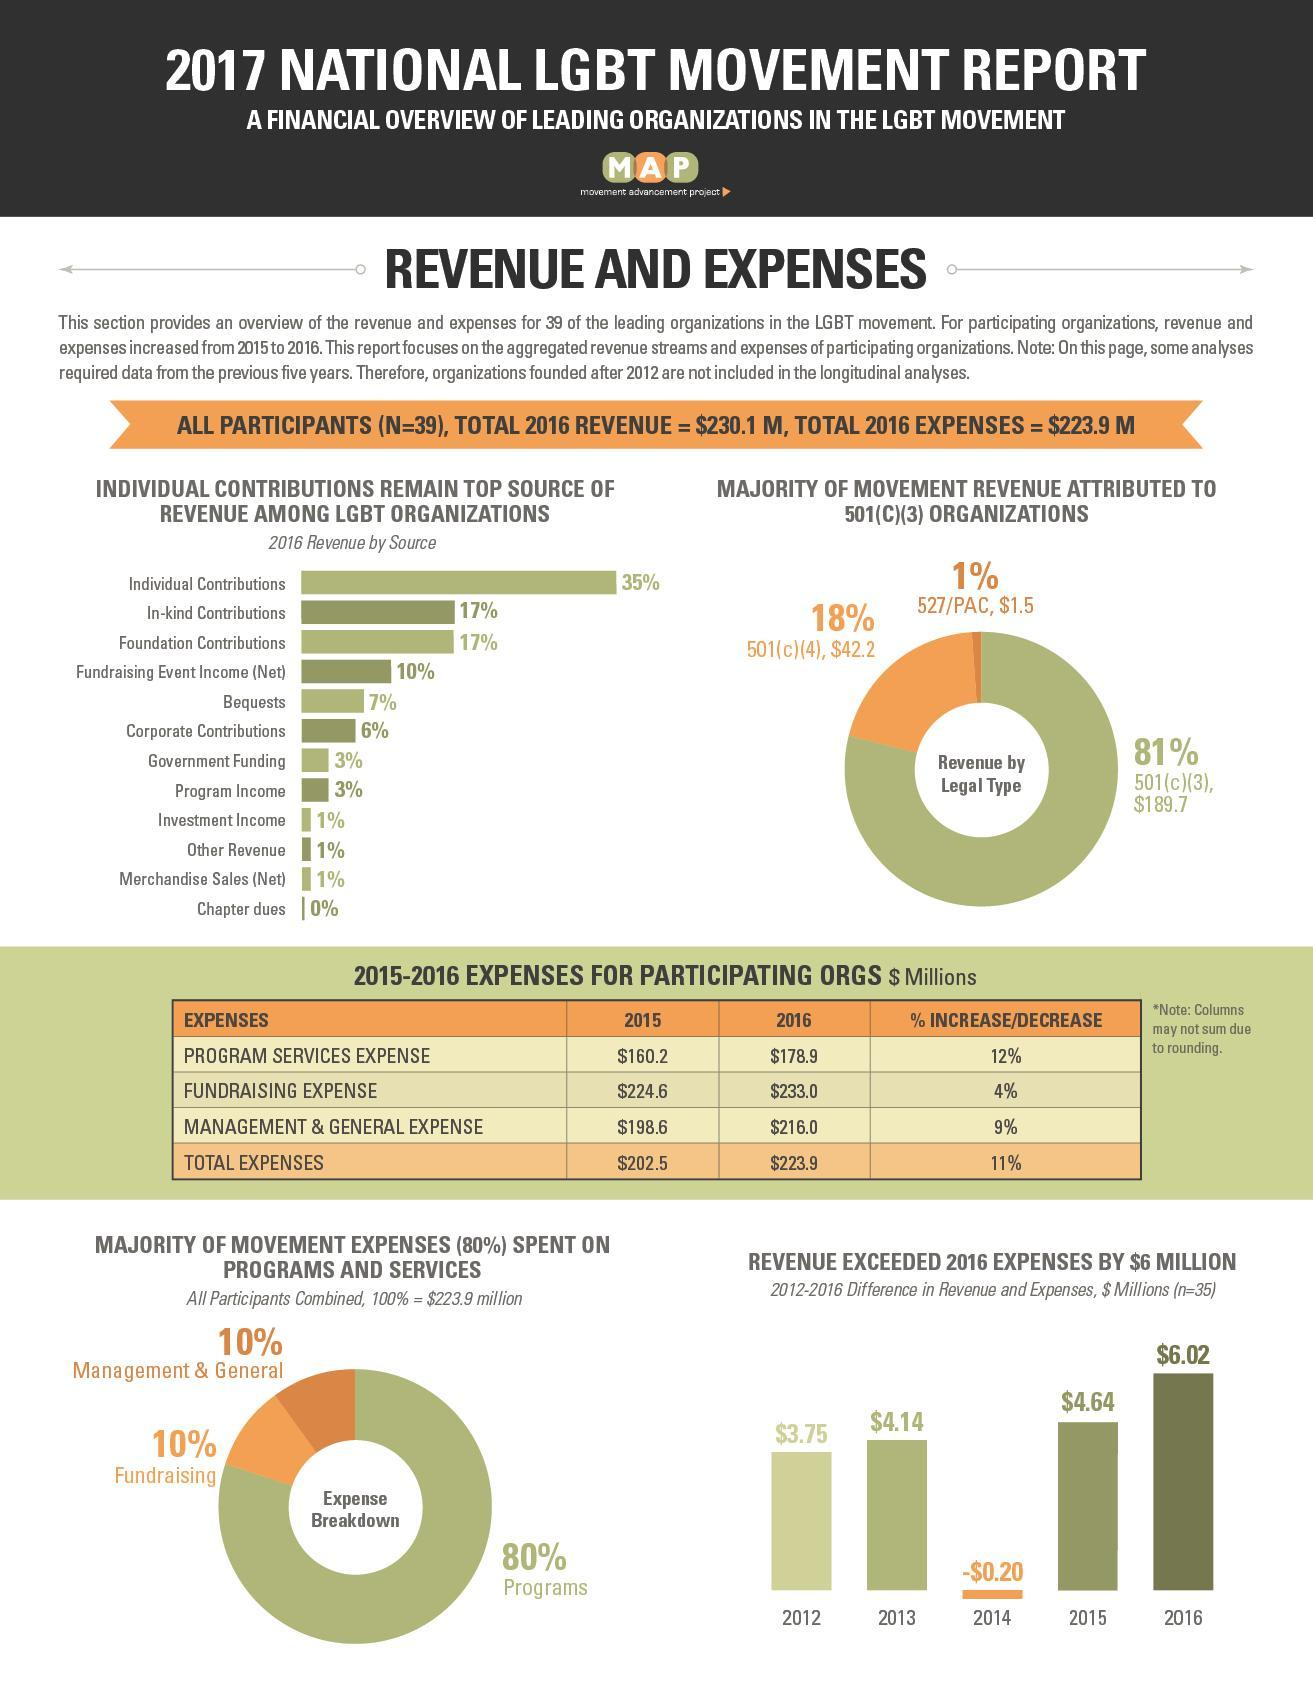Which color represents the programs-grey, orange or red?
Answer the question with a short phrase. grey What is the percentage of chapter dues and other revenue taken together? 1% How many years are there in total in the bar graph? 5 What is the percentage of program income and other revenue taken together? 4% What is the percentage of Programs and Fundraising taken together? 90% What is the percentage of individual contributions and bequests taken together? 42% 